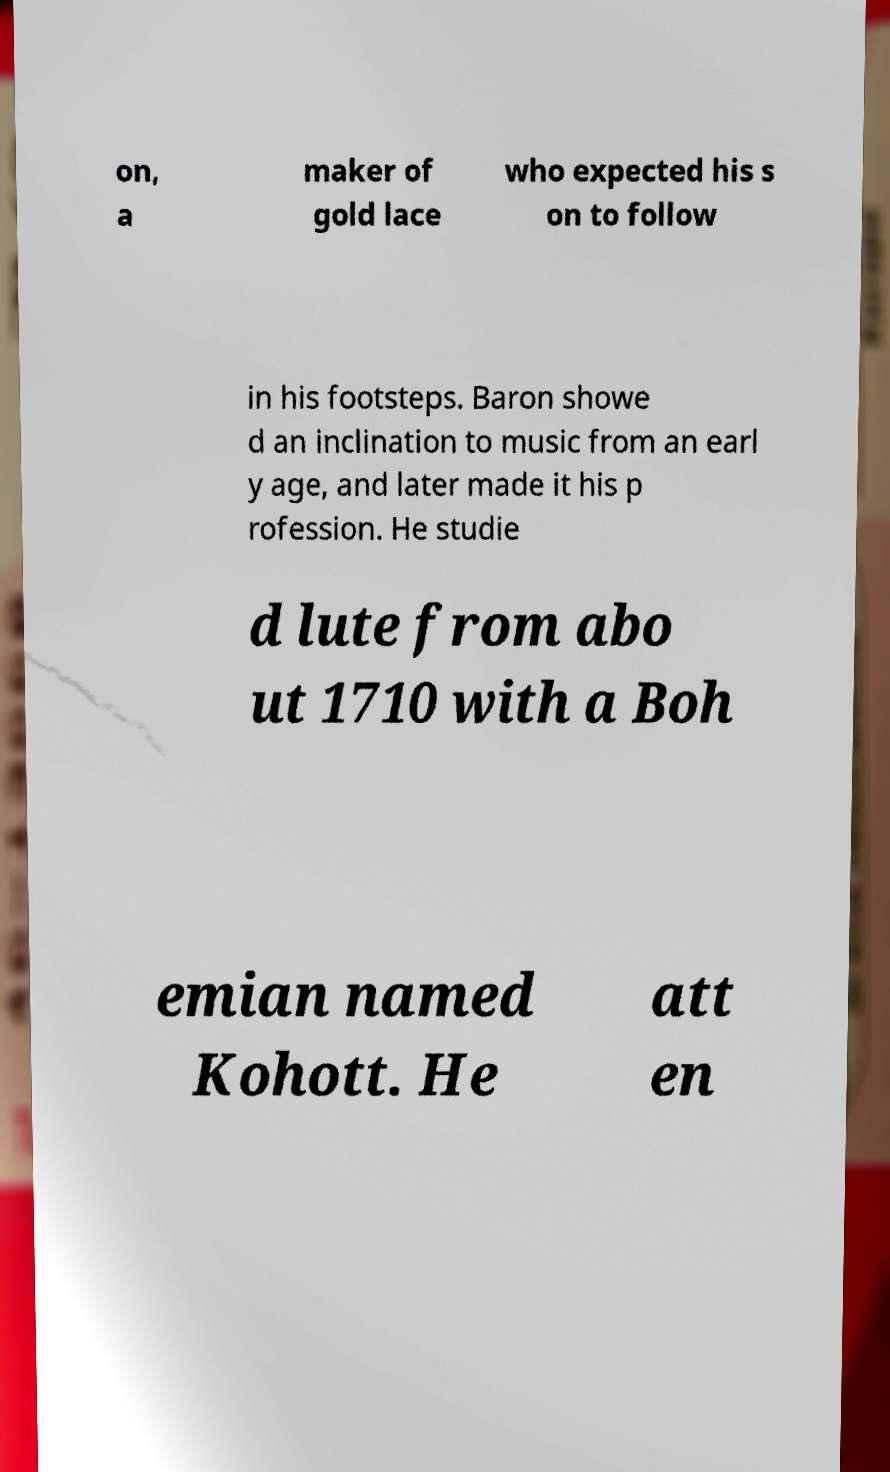Please identify and transcribe the text found in this image. on, a maker of gold lace who expected his s on to follow in his footsteps. Baron showe d an inclination to music from an earl y age, and later made it his p rofession. He studie d lute from abo ut 1710 with a Boh emian named Kohott. He att en 